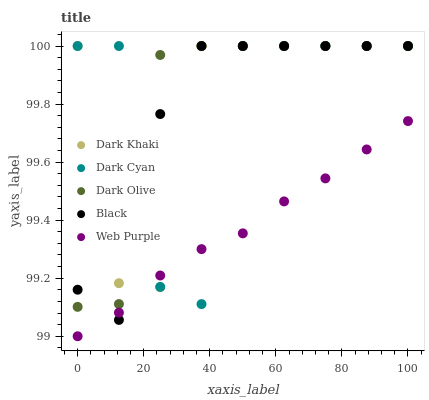Does Web Purple have the minimum area under the curve?
Answer yes or no. Yes. Does Dark Olive have the maximum area under the curve?
Answer yes or no. Yes. Does Dark Cyan have the minimum area under the curve?
Answer yes or no. No. Does Dark Cyan have the maximum area under the curve?
Answer yes or no. No. Is Web Purple the smoothest?
Answer yes or no. Yes. Is Dark Cyan the roughest?
Answer yes or no. Yes. Is Dark Cyan the smoothest?
Answer yes or no. No. Is Web Purple the roughest?
Answer yes or no. No. Does Web Purple have the lowest value?
Answer yes or no. Yes. Does Dark Cyan have the lowest value?
Answer yes or no. No. Does Black have the highest value?
Answer yes or no. Yes. Does Web Purple have the highest value?
Answer yes or no. No. Is Web Purple less than Dark Olive?
Answer yes or no. Yes. Is Dark Olive greater than Web Purple?
Answer yes or no. Yes. Does Dark Olive intersect Black?
Answer yes or no. Yes. Is Dark Olive less than Black?
Answer yes or no. No. Is Dark Olive greater than Black?
Answer yes or no. No. Does Web Purple intersect Dark Olive?
Answer yes or no. No. 